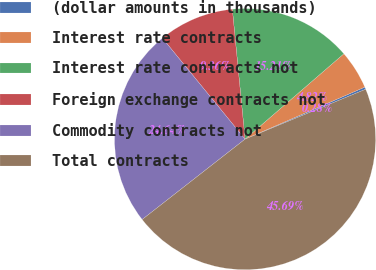Convert chart. <chart><loc_0><loc_0><loc_500><loc_500><pie_chart><fcel>(dollar amounts in thousands)<fcel>Interest rate contracts<fcel>Interest rate contracts not<fcel>Foreign exchange contracts not<fcel>Commodity contracts not<fcel>Total contracts<nl><fcel>0.28%<fcel>4.82%<fcel>15.21%<fcel>9.36%<fcel>24.64%<fcel>45.69%<nl></chart> 